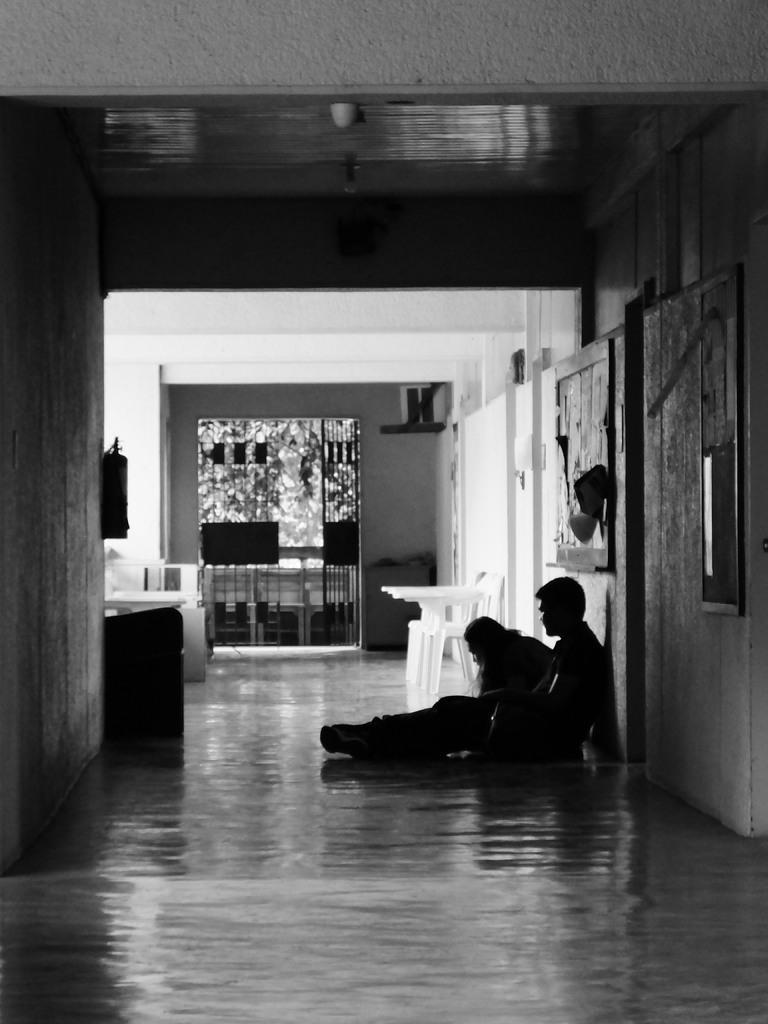In one or two sentences, can you explain what this image depicts? In this image I can see two persons sitting on the floor, the left I can see a frame attached to the wall. Background I can see wall and few pots, and the image is in black and white. 